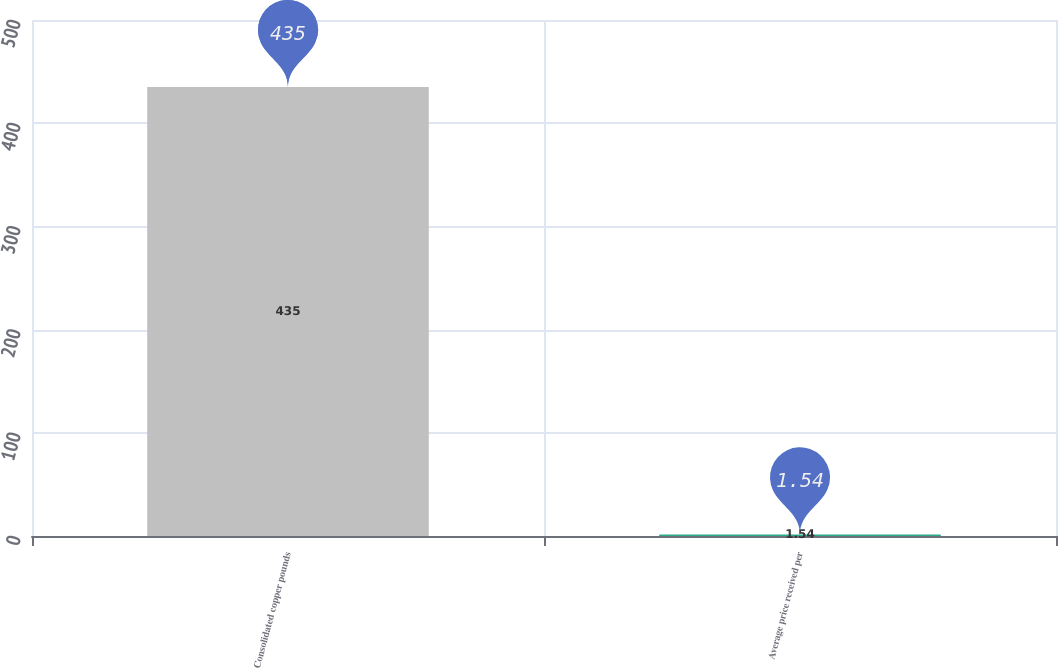<chart> <loc_0><loc_0><loc_500><loc_500><bar_chart><fcel>Consolidated copper pounds<fcel>Average price received per<nl><fcel>435<fcel>1.54<nl></chart> 